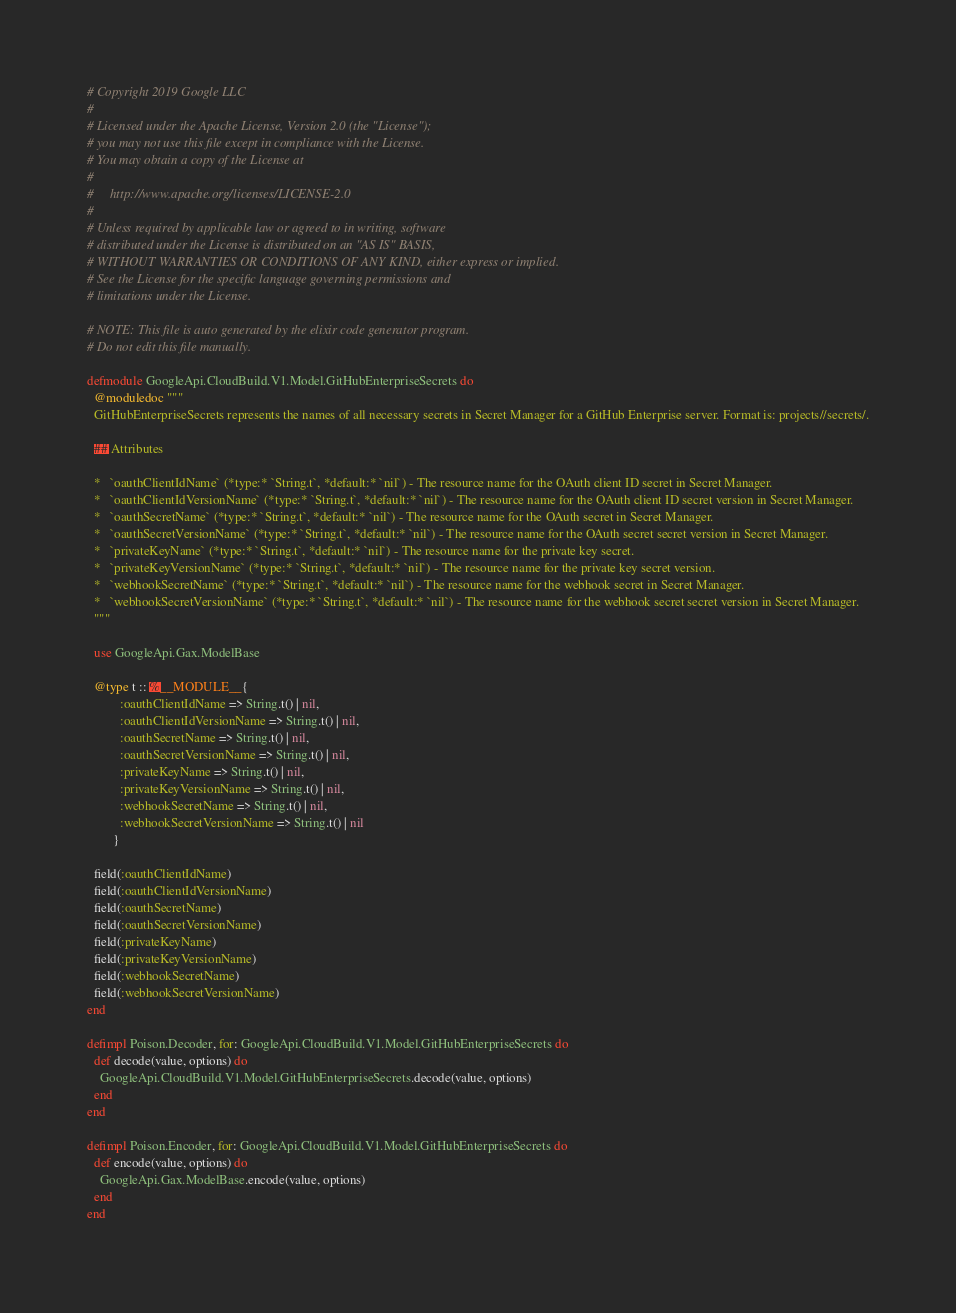<code> <loc_0><loc_0><loc_500><loc_500><_Elixir_># Copyright 2019 Google LLC
#
# Licensed under the Apache License, Version 2.0 (the "License");
# you may not use this file except in compliance with the License.
# You may obtain a copy of the License at
#
#     http://www.apache.org/licenses/LICENSE-2.0
#
# Unless required by applicable law or agreed to in writing, software
# distributed under the License is distributed on an "AS IS" BASIS,
# WITHOUT WARRANTIES OR CONDITIONS OF ANY KIND, either express or implied.
# See the License for the specific language governing permissions and
# limitations under the License.

# NOTE: This file is auto generated by the elixir code generator program.
# Do not edit this file manually.

defmodule GoogleApi.CloudBuild.V1.Model.GitHubEnterpriseSecrets do
  @moduledoc """
  GitHubEnterpriseSecrets represents the names of all necessary secrets in Secret Manager for a GitHub Enterprise server. Format is: projects//secrets/.

  ## Attributes

  *   `oauthClientIdName` (*type:* `String.t`, *default:* `nil`) - The resource name for the OAuth client ID secret in Secret Manager.
  *   `oauthClientIdVersionName` (*type:* `String.t`, *default:* `nil`) - The resource name for the OAuth client ID secret version in Secret Manager.
  *   `oauthSecretName` (*type:* `String.t`, *default:* `nil`) - The resource name for the OAuth secret in Secret Manager.
  *   `oauthSecretVersionName` (*type:* `String.t`, *default:* `nil`) - The resource name for the OAuth secret secret version in Secret Manager.
  *   `privateKeyName` (*type:* `String.t`, *default:* `nil`) - The resource name for the private key secret.
  *   `privateKeyVersionName` (*type:* `String.t`, *default:* `nil`) - The resource name for the private key secret version.
  *   `webhookSecretName` (*type:* `String.t`, *default:* `nil`) - The resource name for the webhook secret in Secret Manager.
  *   `webhookSecretVersionName` (*type:* `String.t`, *default:* `nil`) - The resource name for the webhook secret secret version in Secret Manager.
  """

  use GoogleApi.Gax.ModelBase

  @type t :: %__MODULE__{
          :oauthClientIdName => String.t() | nil,
          :oauthClientIdVersionName => String.t() | nil,
          :oauthSecretName => String.t() | nil,
          :oauthSecretVersionName => String.t() | nil,
          :privateKeyName => String.t() | nil,
          :privateKeyVersionName => String.t() | nil,
          :webhookSecretName => String.t() | nil,
          :webhookSecretVersionName => String.t() | nil
        }

  field(:oauthClientIdName)
  field(:oauthClientIdVersionName)
  field(:oauthSecretName)
  field(:oauthSecretVersionName)
  field(:privateKeyName)
  field(:privateKeyVersionName)
  field(:webhookSecretName)
  field(:webhookSecretVersionName)
end

defimpl Poison.Decoder, for: GoogleApi.CloudBuild.V1.Model.GitHubEnterpriseSecrets do
  def decode(value, options) do
    GoogleApi.CloudBuild.V1.Model.GitHubEnterpriseSecrets.decode(value, options)
  end
end

defimpl Poison.Encoder, for: GoogleApi.CloudBuild.V1.Model.GitHubEnterpriseSecrets do
  def encode(value, options) do
    GoogleApi.Gax.ModelBase.encode(value, options)
  end
end
</code> 